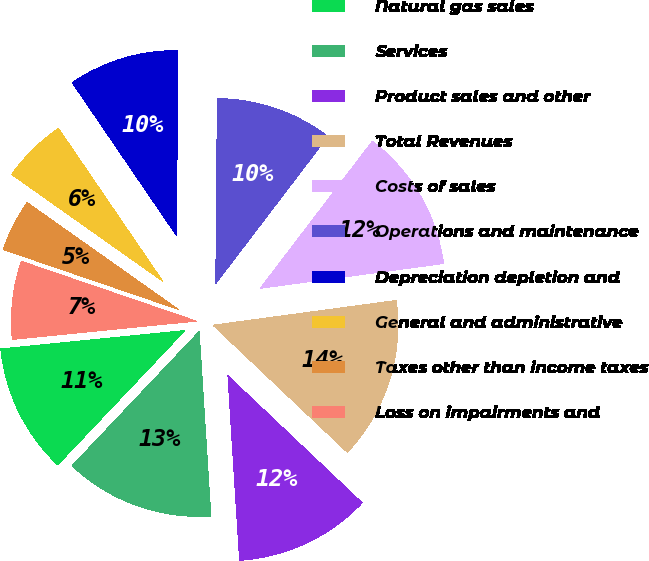<chart> <loc_0><loc_0><loc_500><loc_500><pie_chart><fcel>Natural gas sales<fcel>Services<fcel>Product sales and other<fcel>Total Revenues<fcel>Costs of sales<fcel>Operations and maintenance<fcel>Depreciation depletion and<fcel>General and administrative<fcel>Taxes other than income taxes<fcel>Loss on impairments and<nl><fcel>11.36%<fcel>13.07%<fcel>11.93%<fcel>14.2%<fcel>12.5%<fcel>10.23%<fcel>9.66%<fcel>5.68%<fcel>4.55%<fcel>6.82%<nl></chart> 